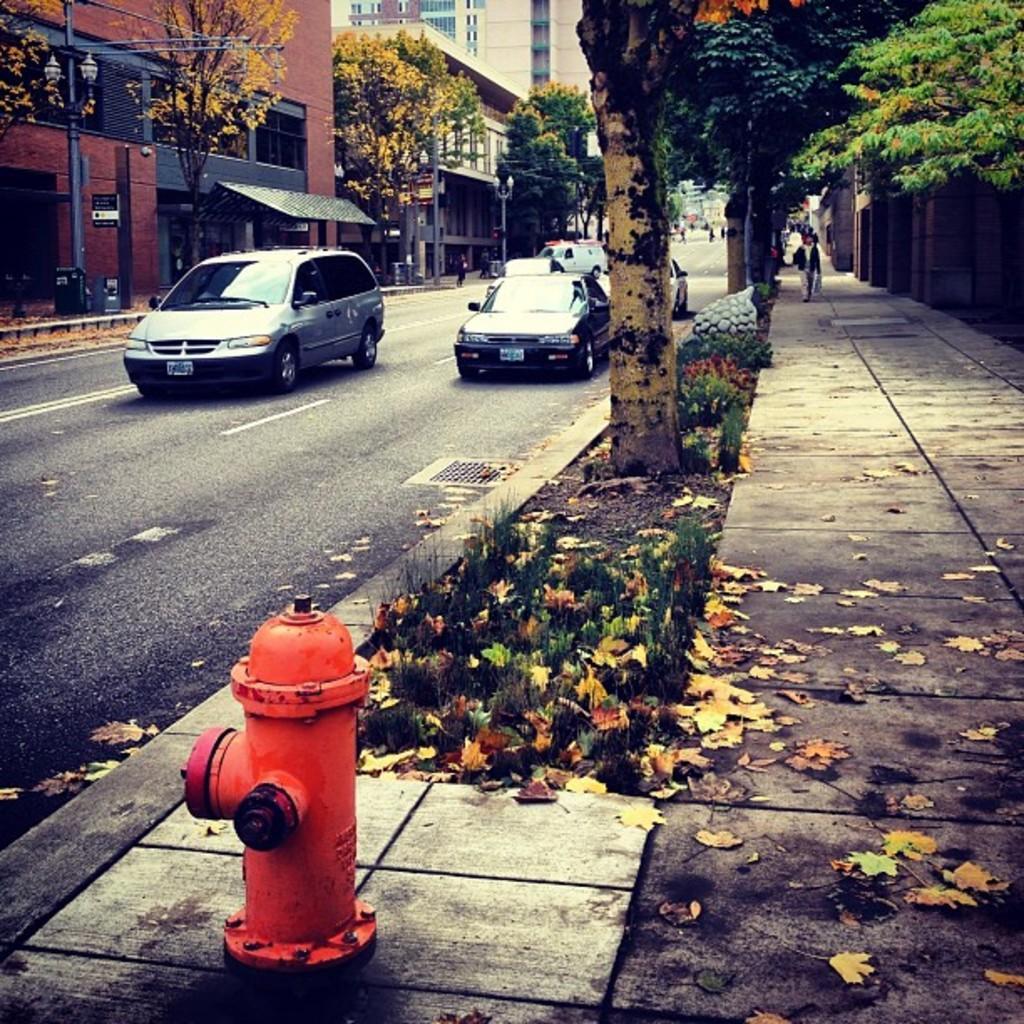Can you describe this image briefly? In this image there are buildings, there are trees, there are vehicles on the road, there is grass, there is a fire hydrant, there is person walking, there is a pole, there are objects on the ground. 